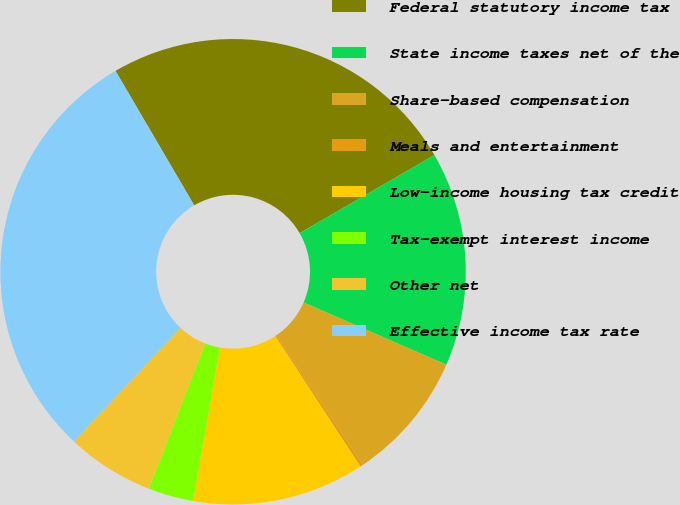<chart> <loc_0><loc_0><loc_500><loc_500><pie_chart><fcel>Federal statutory income tax<fcel>State income taxes net of the<fcel>Share-based compensation<fcel>Meals and entertainment<fcel>Low-income housing tax credit<fcel>Tax-exempt interest income<fcel>Other net<fcel>Effective income tax rate<nl><fcel>25.07%<fcel>14.9%<fcel>9.03%<fcel>0.21%<fcel>11.96%<fcel>3.15%<fcel>6.09%<fcel>29.58%<nl></chart> 